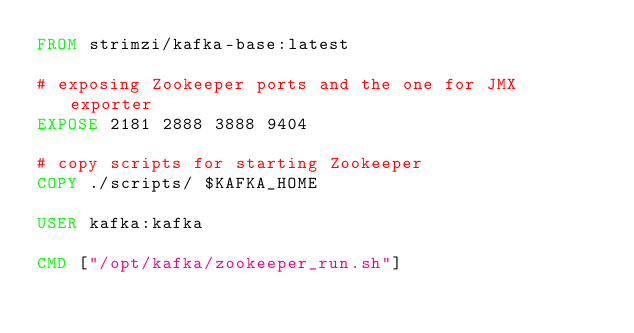<code> <loc_0><loc_0><loc_500><loc_500><_Dockerfile_>FROM strimzi/kafka-base:latest

# exposing Zookeeper ports and the one for JMX exporter
EXPOSE 2181 2888 3888 9404

# copy scripts for starting Zookeeper
COPY ./scripts/ $KAFKA_HOME

USER kafka:kafka

CMD ["/opt/kafka/zookeeper_run.sh"]</code> 